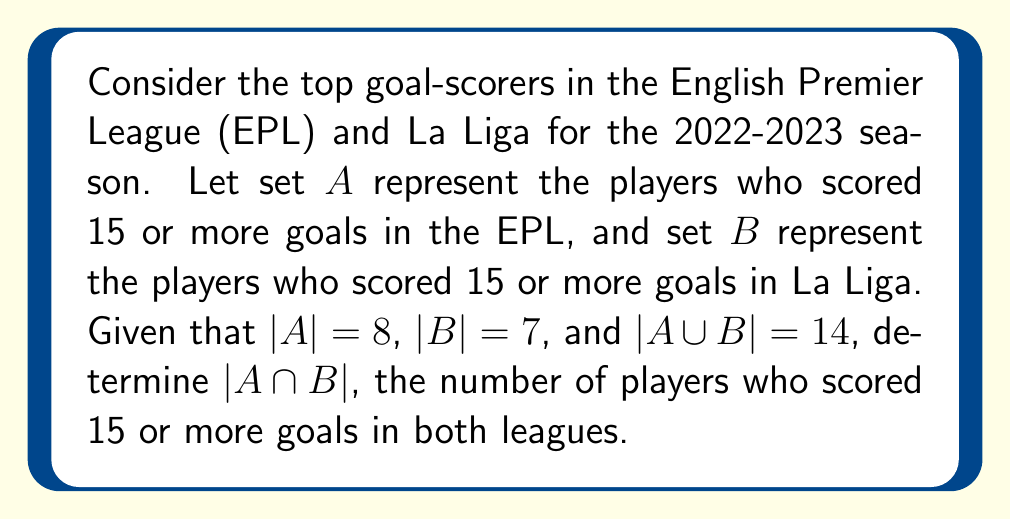Could you help me with this problem? To solve this problem, we'll use the formula for the number of elements in the union of two sets:

$$|A \cup B| = |A| + |B| - |A \cap B|$$

We know:
- $|A| = 8$ (players who scored 15+ goals in EPL)
- $|B| = 7$ (players who scored 15+ goals in La Liga)
- $|A \cup B| = 14$ (total unique players who scored 15+ goals in either league)

Let's substitute these values into the formula:

$$14 = 8 + 7 - |A \cap B|$$

Now, we can solve for $|A \cap B|$:

$$14 = 15 - |A \cap B|$$
$$|A \cap B| = 15 - 14 = 1$$

Therefore, there is 1 player who scored 15 or more goals in both the English Premier League and La Liga during the 2022-2023 season.
Answer: $|A \cap B| = 1$ 